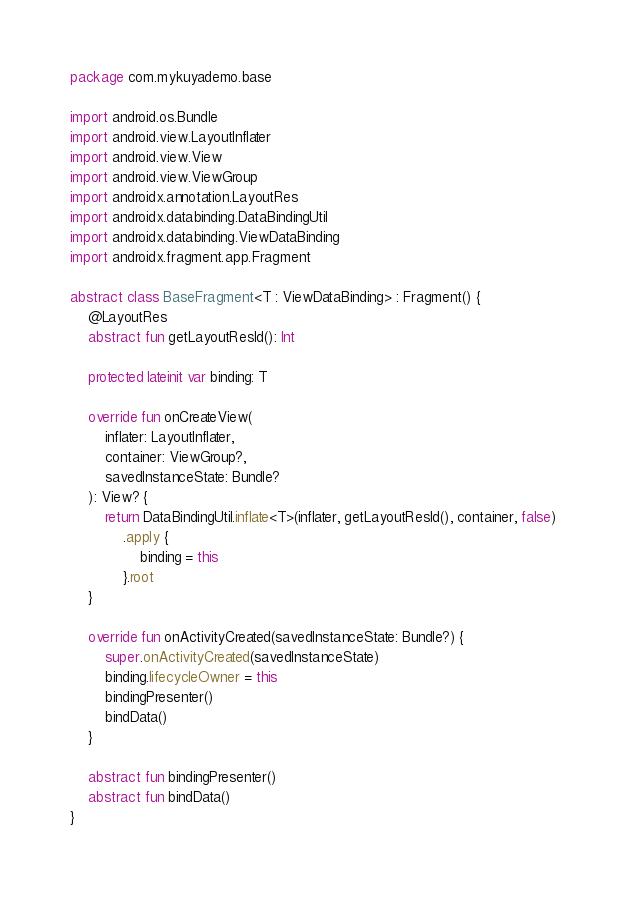Convert code to text. <code><loc_0><loc_0><loc_500><loc_500><_Kotlin_>package com.mykuyademo.base

import android.os.Bundle
import android.view.LayoutInflater
import android.view.View
import android.view.ViewGroup
import androidx.annotation.LayoutRes
import androidx.databinding.DataBindingUtil
import androidx.databinding.ViewDataBinding
import androidx.fragment.app.Fragment

abstract class BaseFragment<T : ViewDataBinding> : Fragment() {
    @LayoutRes
    abstract fun getLayoutResId(): Int

    protected lateinit var binding: T

    override fun onCreateView(
        inflater: LayoutInflater,
        container: ViewGroup?,
        savedInstanceState: Bundle?
    ): View? {
        return DataBindingUtil.inflate<T>(inflater, getLayoutResId(), container, false)
            .apply {
                binding = this
            }.root
    }

    override fun onActivityCreated(savedInstanceState: Bundle?) {
        super.onActivityCreated(savedInstanceState)
        binding.lifecycleOwner = this
        bindingPresenter()
        bindData()
    }

    abstract fun bindingPresenter()
    abstract fun bindData()
}</code> 